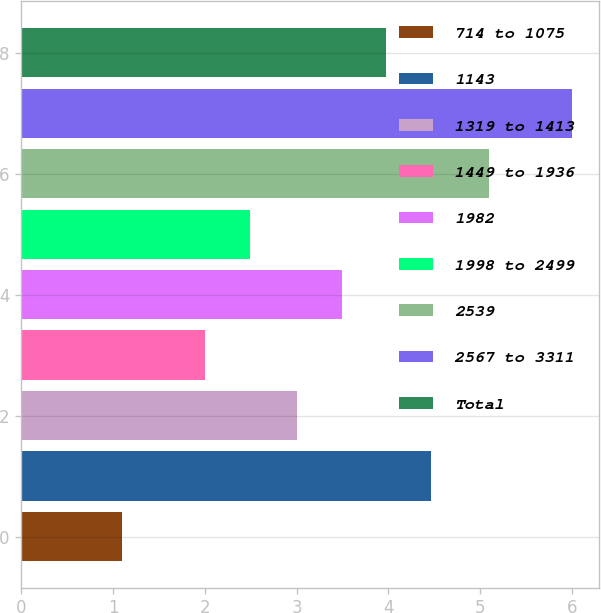<chart> <loc_0><loc_0><loc_500><loc_500><bar_chart><fcel>714 to 1075<fcel>1143<fcel>1319 to 1413<fcel>1449 to 1936<fcel>1982<fcel>1998 to 2499<fcel>2539<fcel>2567 to 3311<fcel>Total<nl><fcel>1.1<fcel>4.47<fcel>3<fcel>2<fcel>3.49<fcel>2.49<fcel>5.1<fcel>6<fcel>3.98<nl></chart> 